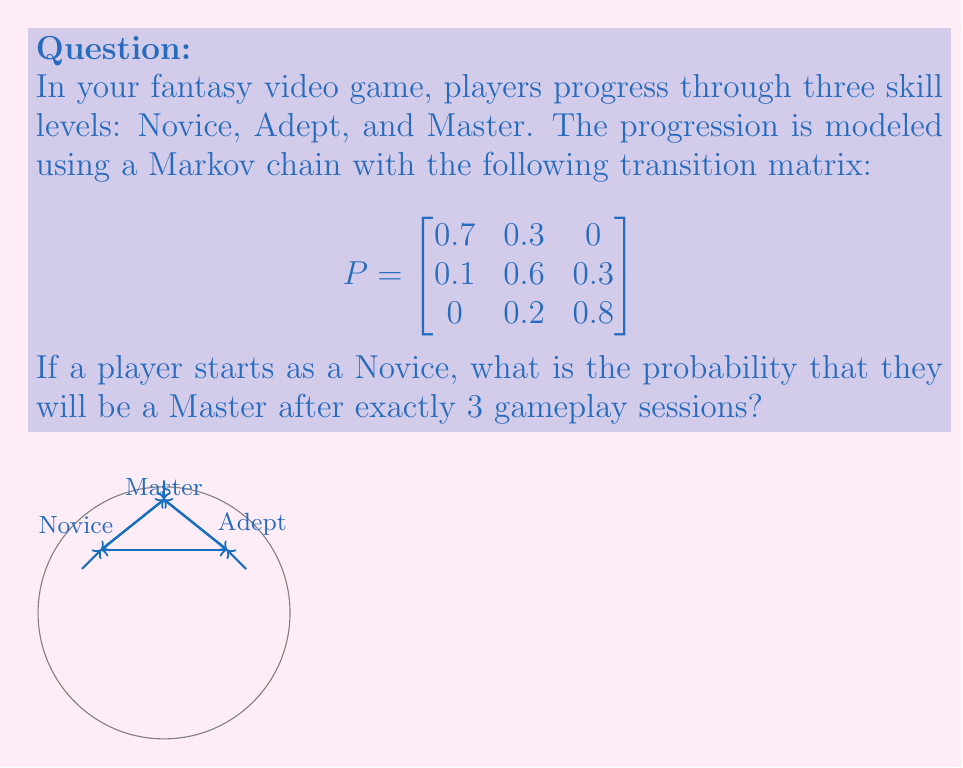Can you answer this question? To solve this problem, we need to calculate the 3-step transition probability from Novice to Master. Let's break it down step-by-step:

1) First, we need to calculate $P^3$, which represents the transition probabilities after 3 steps. We can do this by multiplying the matrix P by itself three times:

   $P^3 = P \times P \times P$

2) Using matrix multiplication (which can be done using a calculator or computer algebra system), we get:

   $$P^3 = \begin{bmatrix}
   0.37 & 0.39 & 0.24 \\
   0.19 & 0.43 & 0.38 \\
   0.08 & 0.34 & 0.58
   \end{bmatrix}$$

3) The probability we're looking for is the entry in the first row (representing the starting state of Novice) and third column (representing the ending state of Master) of this matrix.

4) Therefore, the probability of a player starting as a Novice and becoming a Master after exactly 3 gameplay sessions is 0.24 or 24%.
Answer: 0.24 